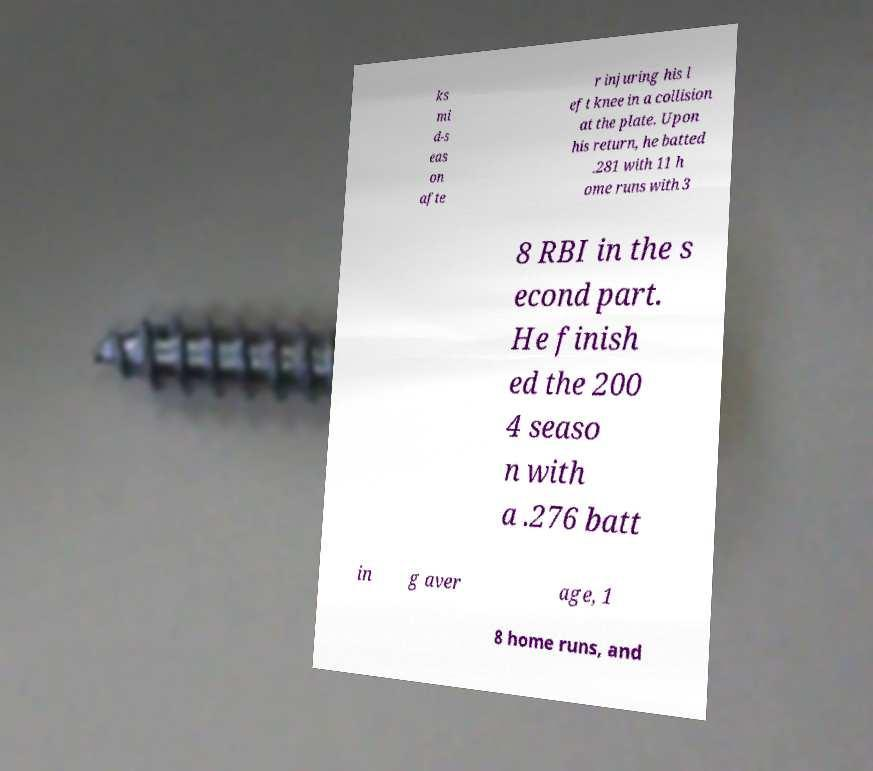Please read and relay the text visible in this image. What does it say? ks mi d-s eas on afte r injuring his l eft knee in a collision at the plate. Upon his return, he batted .281 with 11 h ome runs with 3 8 RBI in the s econd part. He finish ed the 200 4 seaso n with a .276 batt in g aver age, 1 8 home runs, and 